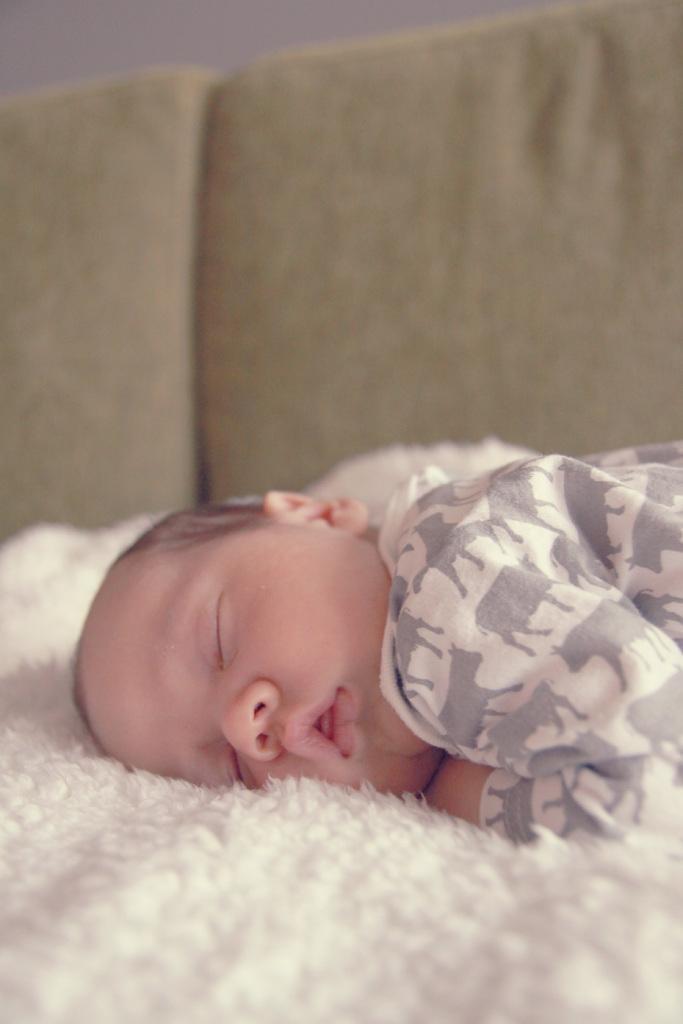Describe this image in one or two sentences. In this image a baby is sleeping on a sofa. 